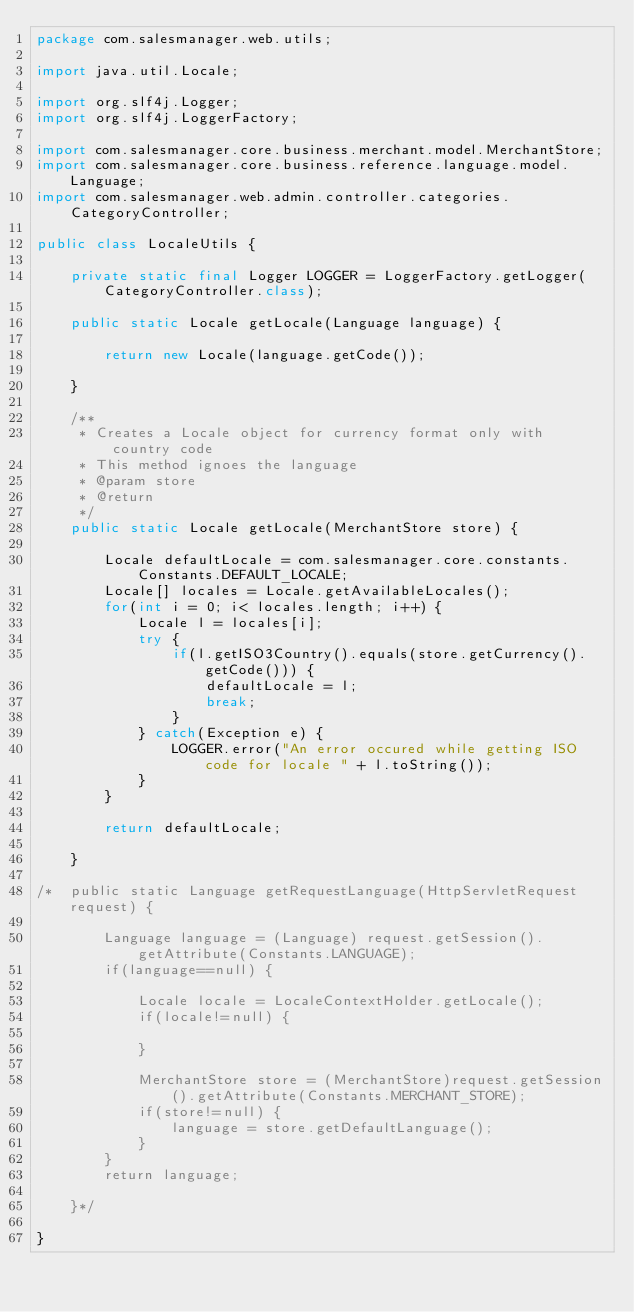Convert code to text. <code><loc_0><loc_0><loc_500><loc_500><_Java_>package com.salesmanager.web.utils;

import java.util.Locale;

import org.slf4j.Logger;
import org.slf4j.LoggerFactory;

import com.salesmanager.core.business.merchant.model.MerchantStore;
import com.salesmanager.core.business.reference.language.model.Language;
import com.salesmanager.web.admin.controller.categories.CategoryController;

public class LocaleUtils {
	
	private static final Logger LOGGER = LoggerFactory.getLogger(CategoryController.class);
	
	public static Locale getLocale(Language language) {
		
		return new Locale(language.getCode());
		
	}
	
	/**
	 * Creates a Locale object for currency format only with country code
	 * This method ignoes the language
	 * @param store
	 * @return
	 */
	public static Locale getLocale(MerchantStore store) {
		
		Locale defaultLocale = com.salesmanager.core.constants.Constants.DEFAULT_LOCALE;
		Locale[] locales = Locale.getAvailableLocales();
		for(int i = 0; i< locales.length; i++) {
			Locale l = locales[i];
			try {
				if(l.getISO3Country().equals(store.getCurrency().getCode())) {
					defaultLocale = l;
					break;
				}
			} catch(Exception e) {
				LOGGER.error("An error occured while getting ISO code for locale " + l.toString());
			}
		}
		
		return defaultLocale;
		
	}
	
/*	public static Language getRequestLanguage(HttpServletRequest request) {
		
		Language language = (Language) request.getSession().getAttribute(Constants.LANGUAGE);
		if(language==null) {
			
			Locale locale = LocaleContextHolder.getLocale();
			if(locale!=null) {
				
			}
			
			MerchantStore store = (MerchantStore)request.getSession().getAttribute(Constants.MERCHANT_STORE);
			if(store!=null) {
				language = store.getDefaultLanguage();
			}
		}
		return language;
		
	}*/

}
</code> 